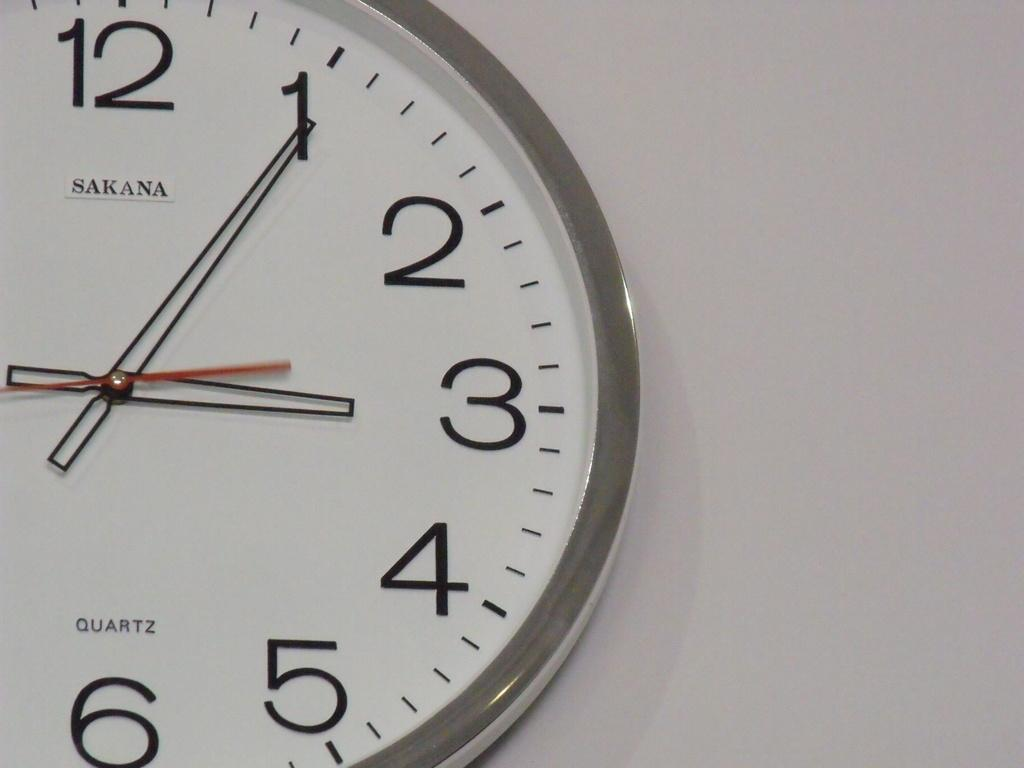<image>
Provide a brief description of the given image. a clock that has the number 12 on it 